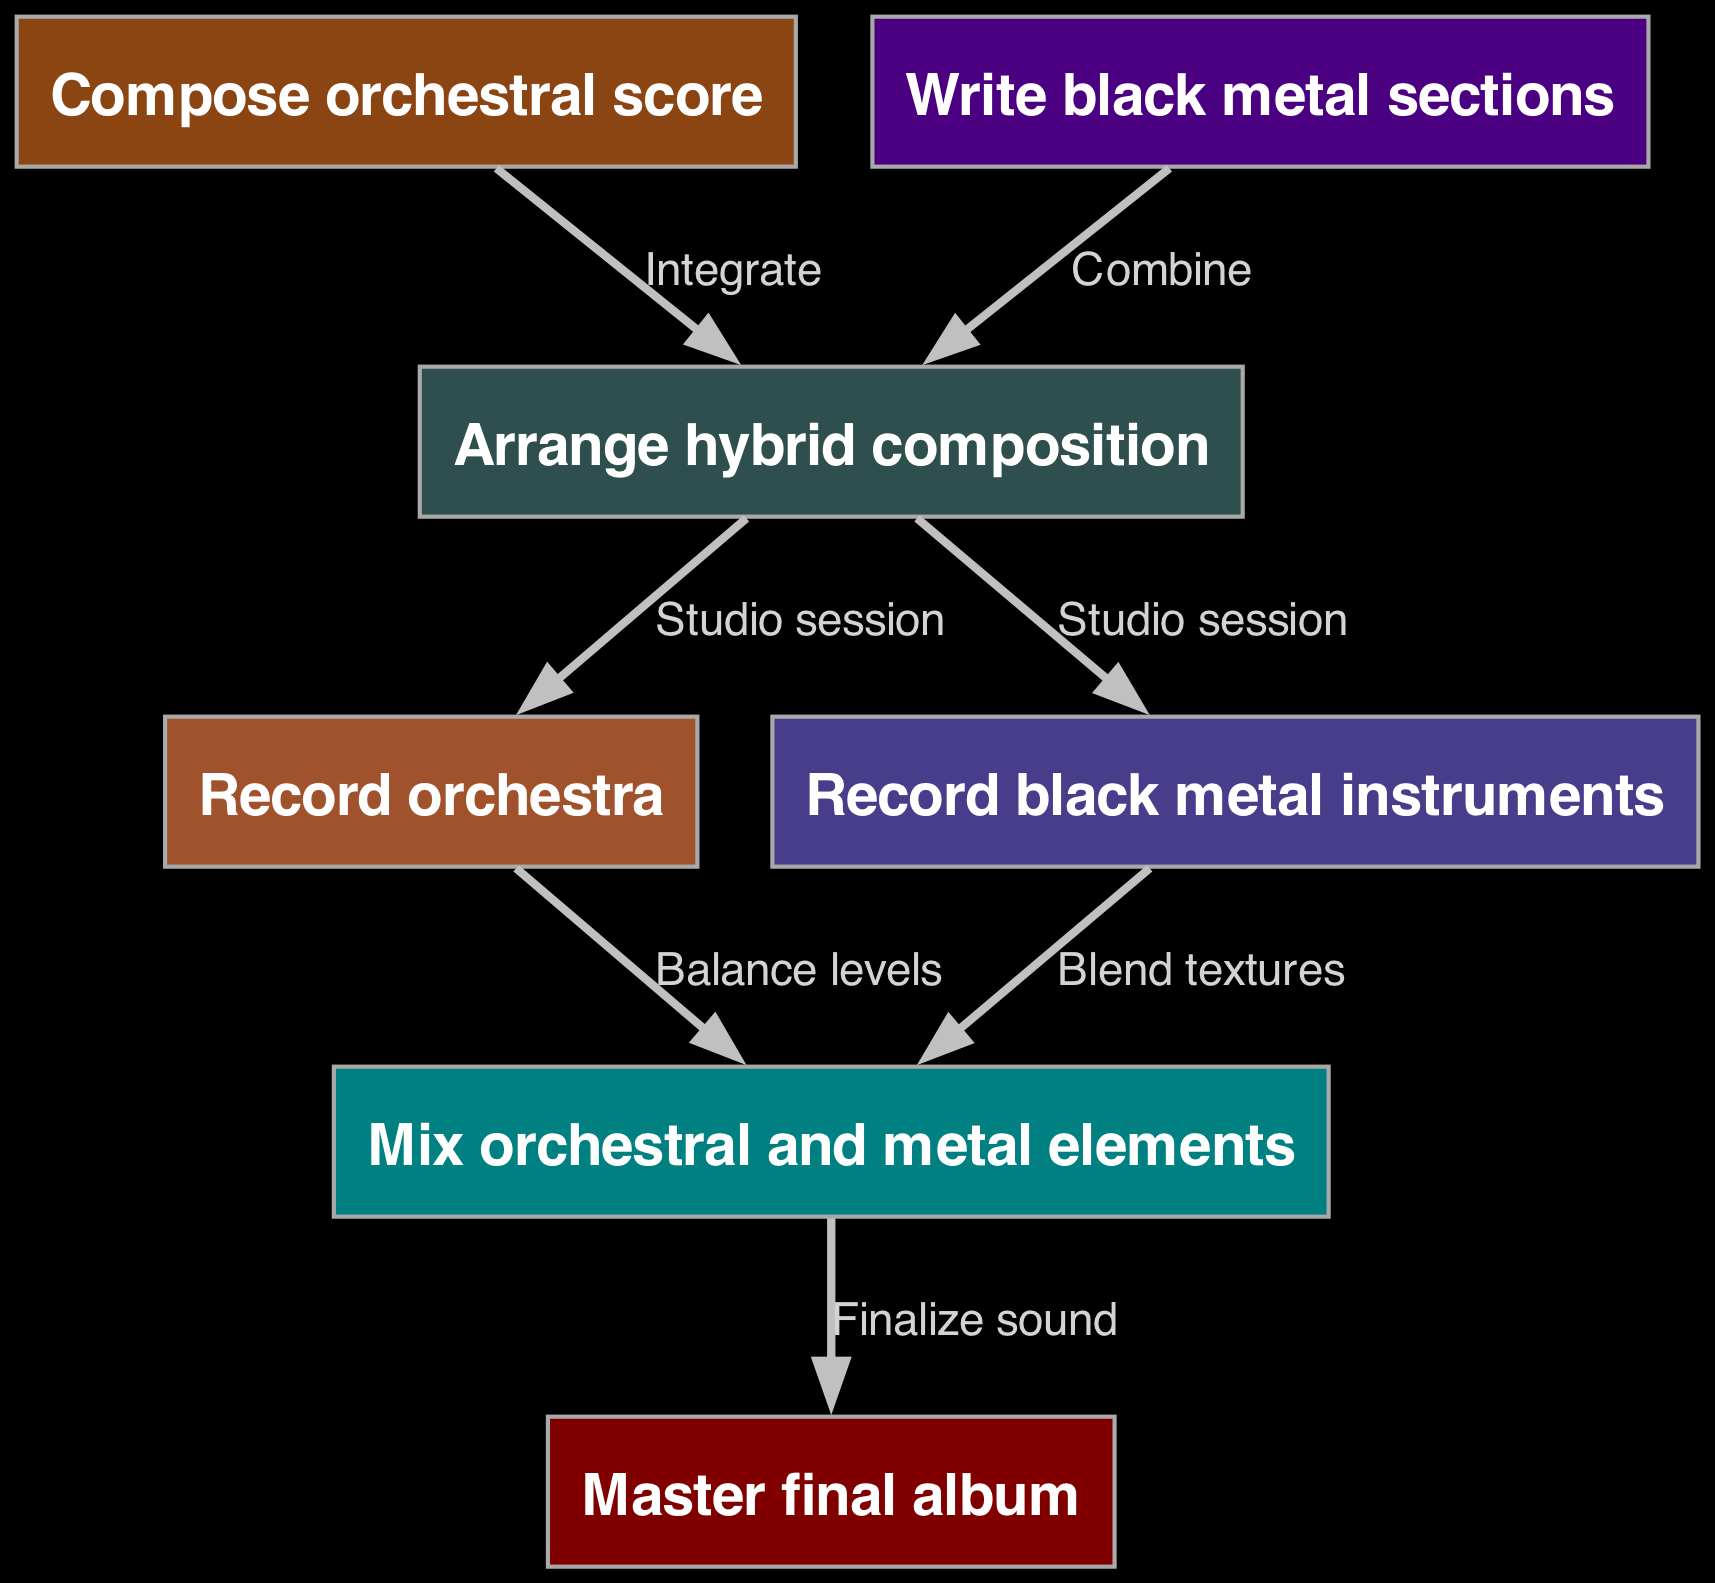What is the first step in the production workflow? The first step is "Compose orchestral score", as indicated by the first node in the diagram.
Answer: Compose orchestral score How many nodes are there in the workflow? The diagram contains a total of 7 nodes, which represent the various stages in the production workflow from composition to mastering.
Answer: 7 What color represents the "Master final album"? The "Master final album" node is represented in maroon color, as defined in the color scheme for that node type.
Answer: Maroon What is done after recording black metal instruments? After recording black metal instruments, the process moves to "Mix orchestral and metal elements", as shown by the edge connecting node 5 and node 6.
Answer: Mix orchestral and metal elements Which two steps are combined to create the hybrid composition? The hybrid composition is created by integrating the "Compose orchestral score" and "Write black metal sections", as indicated by the arrows leading to the node for arrangement.
Answer: Integrate and Combine What is the last step in the production workflow? The final step in the workflow is "Master final album", which is the last node in the diagram, indicating the completion of the production process.
Answer: Master final album Which stage involves balancing levels? The stage that involves balancing levels is "Mix orchestral and metal elements", as indicated by the edge that connects the recordings to the mixing process.
Answer: Mix orchestral and metal elements What type of recording occurs for both orchestra and black metal instruments? The type of recording that occurs for both is referred to as "Studio session", as noted by the edges leading out from the arrangement node.
Answer: Studio session 